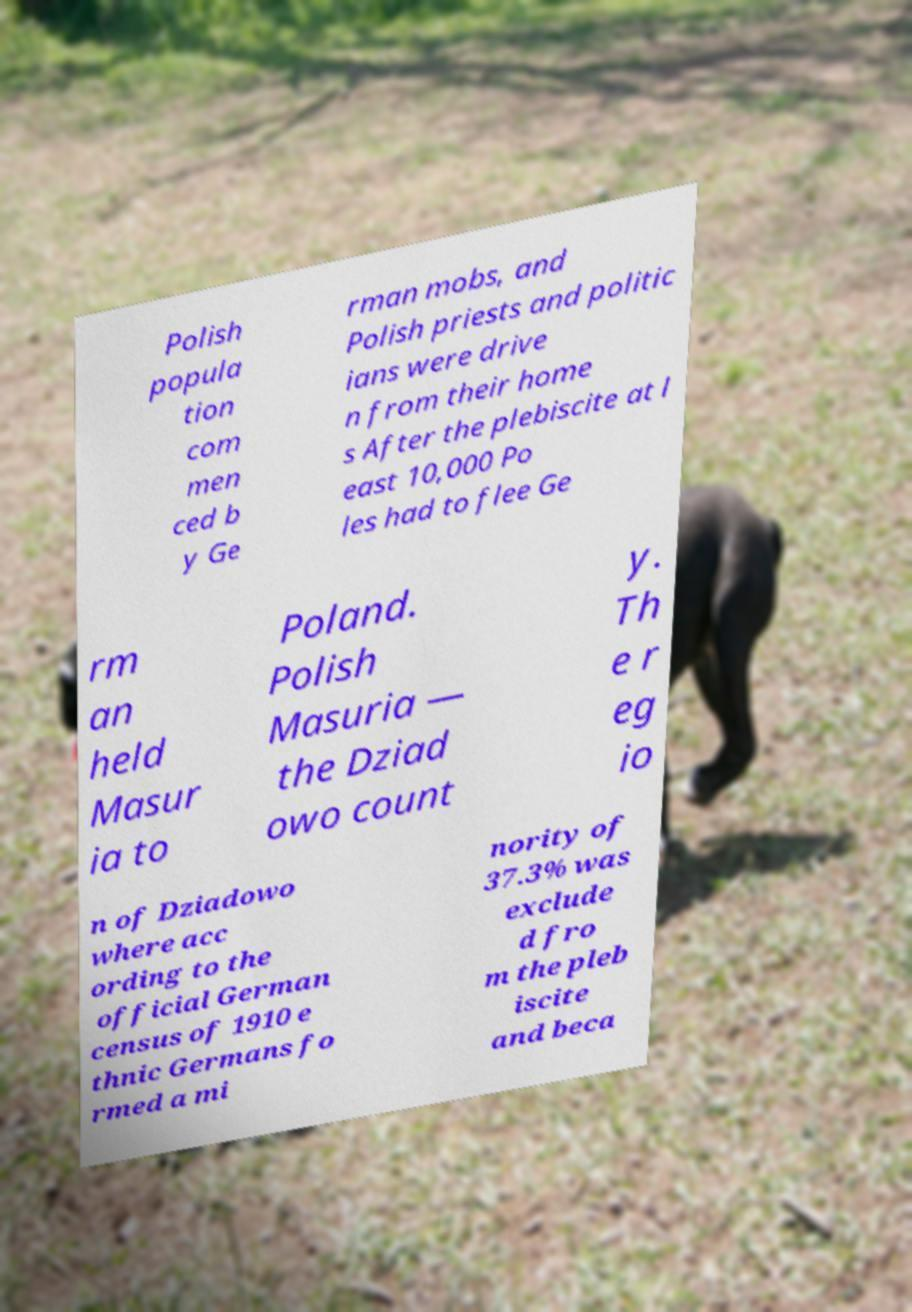Could you assist in decoding the text presented in this image and type it out clearly? Polish popula tion com men ced b y Ge rman mobs, and Polish priests and politic ians were drive n from their home s After the plebiscite at l east 10,000 Po les had to flee Ge rm an held Masur ia to Poland. Polish Masuria — the Dziad owo count y. Th e r eg io n of Dziadowo where acc ording to the official German census of 1910 e thnic Germans fo rmed a mi nority of 37.3% was exclude d fro m the pleb iscite and beca 